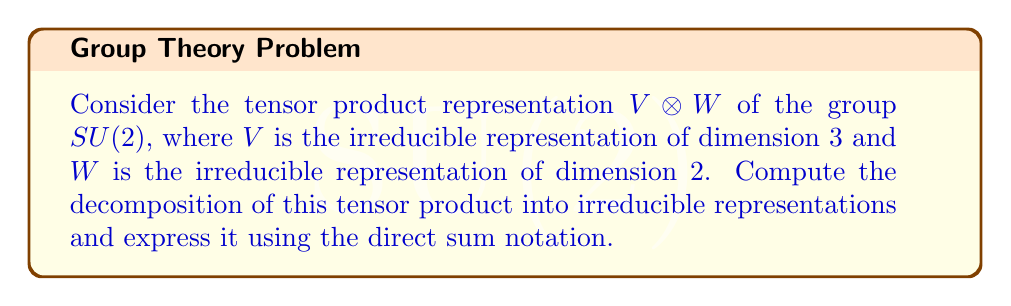Show me your answer to this math problem. To decompose the tensor product representation $V \otimes W$ for $SU(2)$, we follow these steps:

1) First, recall that for $SU(2)$, irreducible representations are labeled by their dimension. Let's denote the $n$-dimensional irreducible representation as $V_n$.

2) In this case, $V = V_3$ (3-dimensional) and $W = V_2$ (2-dimensional).

3) For $SU(2)$, we can use the Clebsch-Gordan formula:

   $$V_j \otimes V_k \cong \bigoplus_{i=|j-k|}^{j+k} V_i$$

   where the sum is taken over integers $i$ from $|j-k|$ to $j+k$.

4) In our problem, $j = 1$ (because $\dim V_3 = 2j+1 = 3$) and $k = \frac{1}{2}$ (because $\dim V_2 = 2k+1 = 2$).

5) Applying the formula:

   $$V_3 \otimes V_2 \cong \bigoplus_{i=|1-\frac{1}{2}|}^{1+\frac{1}{2}} V_i$$

6) This gives us:

   $$V_3 \otimes V_2 \cong V_{\frac{1}{2}} \oplus V_{\frac{3}{2}} \oplus V_{\frac{5}{2}}$$

7) Converting back to dimensions:

   $$V_3 \otimes V_2 \cong V_2 \oplus V_4 \oplus V_6$$

This decomposition shows how the 6-dimensional space $V_3 \otimes V_2$ breaks down into irreducible subrepresentations.
Answer: $V_3 \otimes V_2 \cong V_2 \oplus V_4 \oplus V_6$ 